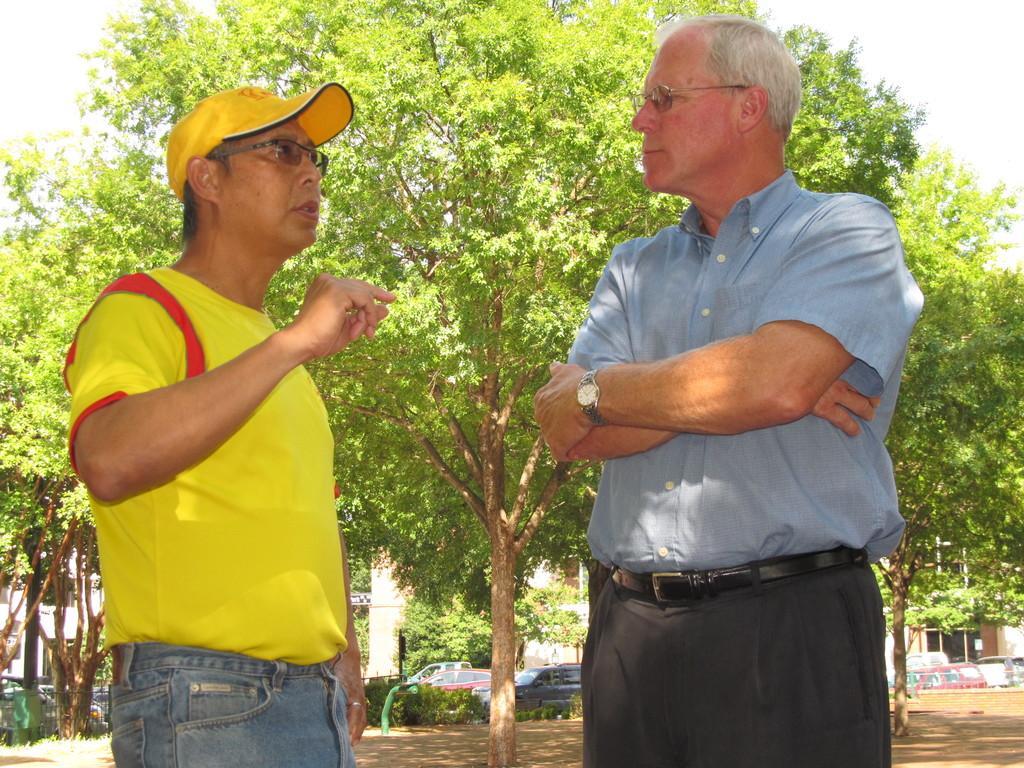Please provide a concise description of this image. In this picture I can see there is a man standing at the left side, she is wearing spectacles and a hat. There is a man standing on the right side and there are trees in the backdrop, there is a building in the backdrop. 